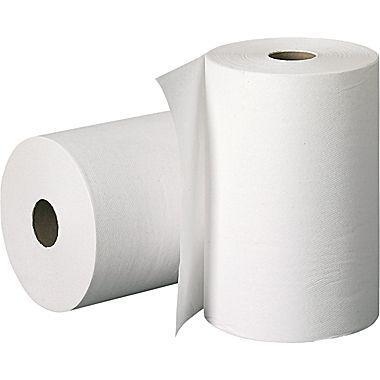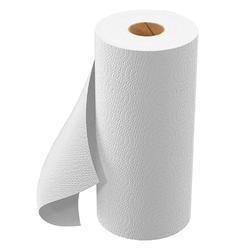The first image is the image on the left, the second image is the image on the right. For the images shown, is this caption "there are exactly two rolls of paper in the image on the left" true? Answer yes or no. Yes. 